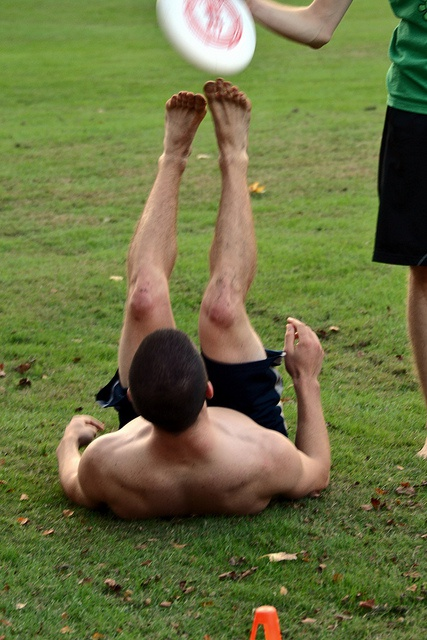Describe the objects in this image and their specific colors. I can see people in green, black, tan, gray, and maroon tones, people in green, black, olive, and darkgreen tones, and frisbee in green, white, darkgray, lightpink, and pink tones in this image. 